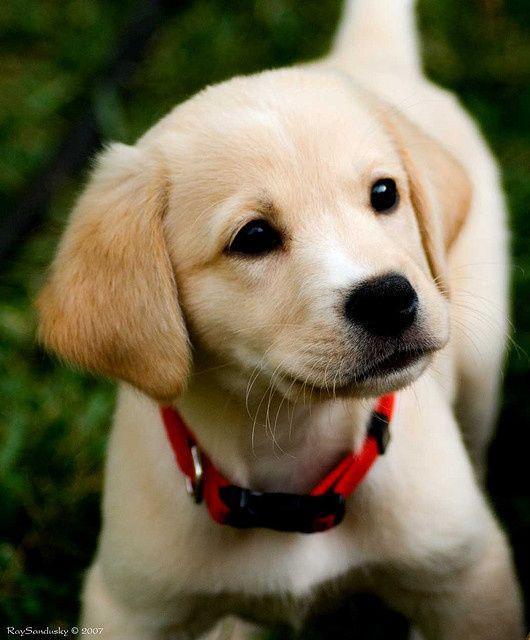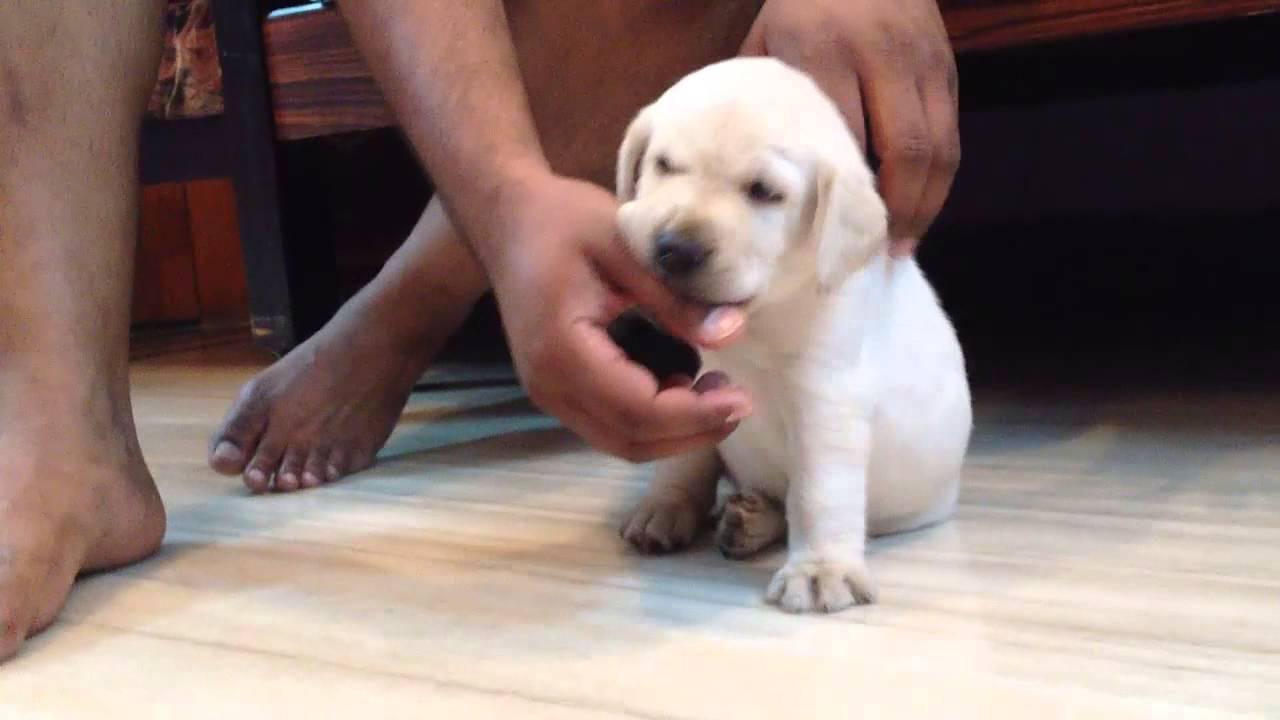The first image is the image on the left, the second image is the image on the right. Considering the images on both sides, is "there are two puppies in the image pair" valid? Answer yes or no. Yes. The first image is the image on the left, the second image is the image on the right. Considering the images on both sides, is "One dog has something around its neck." valid? Answer yes or no. Yes. 